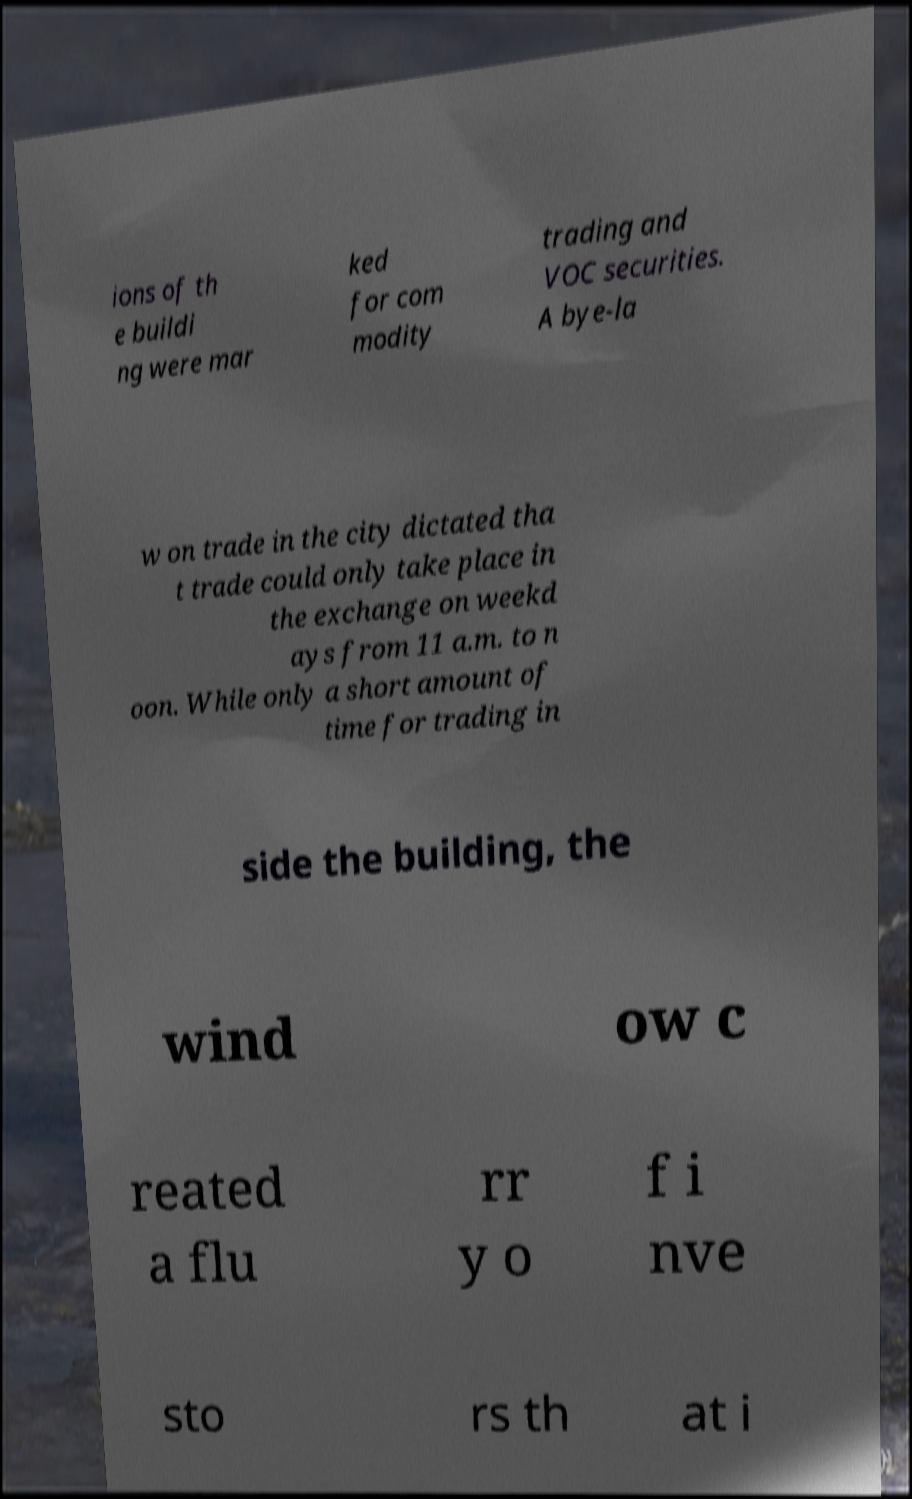Please identify and transcribe the text found in this image. ions of th e buildi ng were mar ked for com modity trading and VOC securities. A bye-la w on trade in the city dictated tha t trade could only take place in the exchange on weekd ays from 11 a.m. to n oon. While only a short amount of time for trading in side the building, the wind ow c reated a flu rr y o f i nve sto rs th at i 